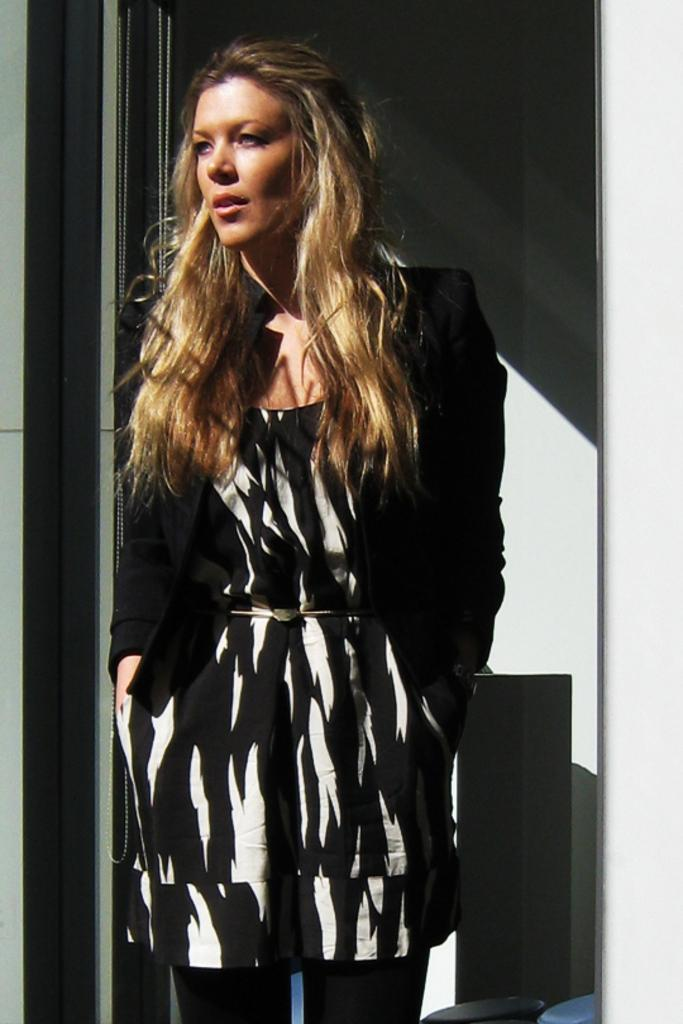Who is the main subject in the image? There is a woman in the image. What is the woman wearing? The woman is wearing a black and white dress. How is the woman described? The woman is described as stunning. What can be seen in the background of the image? There is a wall and other objects visible in the background of the image. What type of locket is the woman wearing in the image? There is no locket visible in the image. What is the woman learning in the image? There is no indication of learning in the image. 